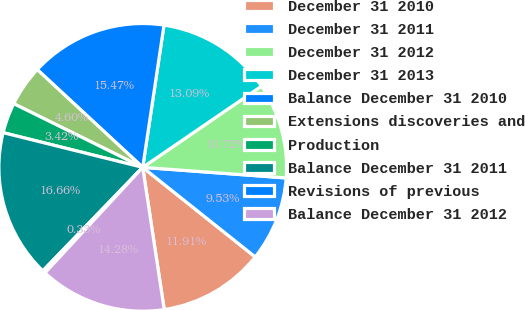<chart> <loc_0><loc_0><loc_500><loc_500><pie_chart><fcel>December 31 2010<fcel>December 31 2011<fcel>December 31 2012<fcel>December 31 2013<fcel>Balance December 31 2010<fcel>Extensions discoveries and<fcel>Production<fcel>Balance December 31 2011<fcel>Revisions of previous<fcel>Balance December 31 2012<nl><fcel>11.91%<fcel>9.53%<fcel>10.72%<fcel>13.09%<fcel>15.47%<fcel>4.6%<fcel>3.42%<fcel>16.66%<fcel>0.33%<fcel>14.28%<nl></chart> 